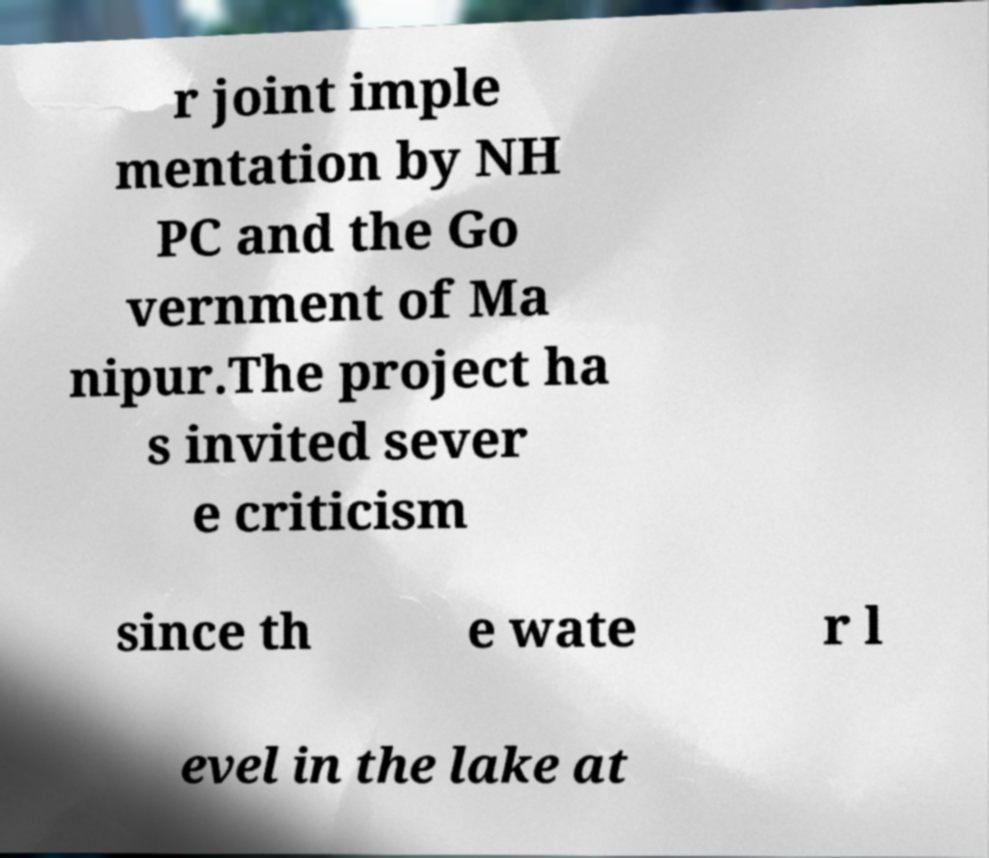Could you assist in decoding the text presented in this image and type it out clearly? r joint imple mentation by NH PC and the Go vernment of Ma nipur.The project ha s invited sever e criticism since th e wate r l evel in the lake at 